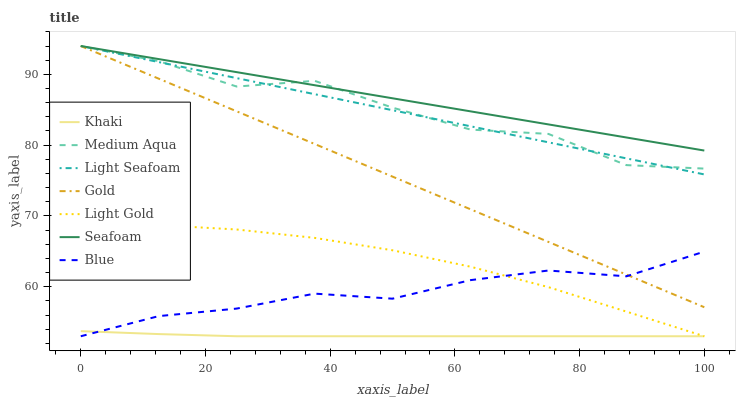Does Khaki have the minimum area under the curve?
Answer yes or no. Yes. Does Seafoam have the maximum area under the curve?
Answer yes or no. Yes. Does Gold have the minimum area under the curve?
Answer yes or no. No. Does Gold have the maximum area under the curve?
Answer yes or no. No. Is Gold the smoothest?
Answer yes or no. Yes. Is Medium Aqua the roughest?
Answer yes or no. Yes. Is Khaki the smoothest?
Answer yes or no. No. Is Khaki the roughest?
Answer yes or no. No. Does Gold have the lowest value?
Answer yes or no. No. Does Khaki have the highest value?
Answer yes or no. No. Is Light Gold less than Seafoam?
Answer yes or no. Yes. Is Light Seafoam greater than Blue?
Answer yes or no. Yes. Does Light Gold intersect Seafoam?
Answer yes or no. No. 